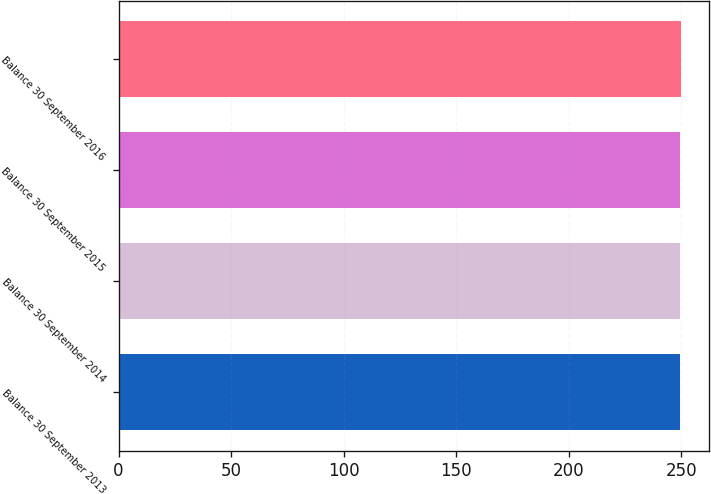<chart> <loc_0><loc_0><loc_500><loc_500><bar_chart><fcel>Balance 30 September 2013<fcel>Balance 30 September 2014<fcel>Balance 30 September 2015<fcel>Balance 30 September 2016<nl><fcel>249.4<fcel>249.5<fcel>249.6<fcel>249.7<nl></chart> 